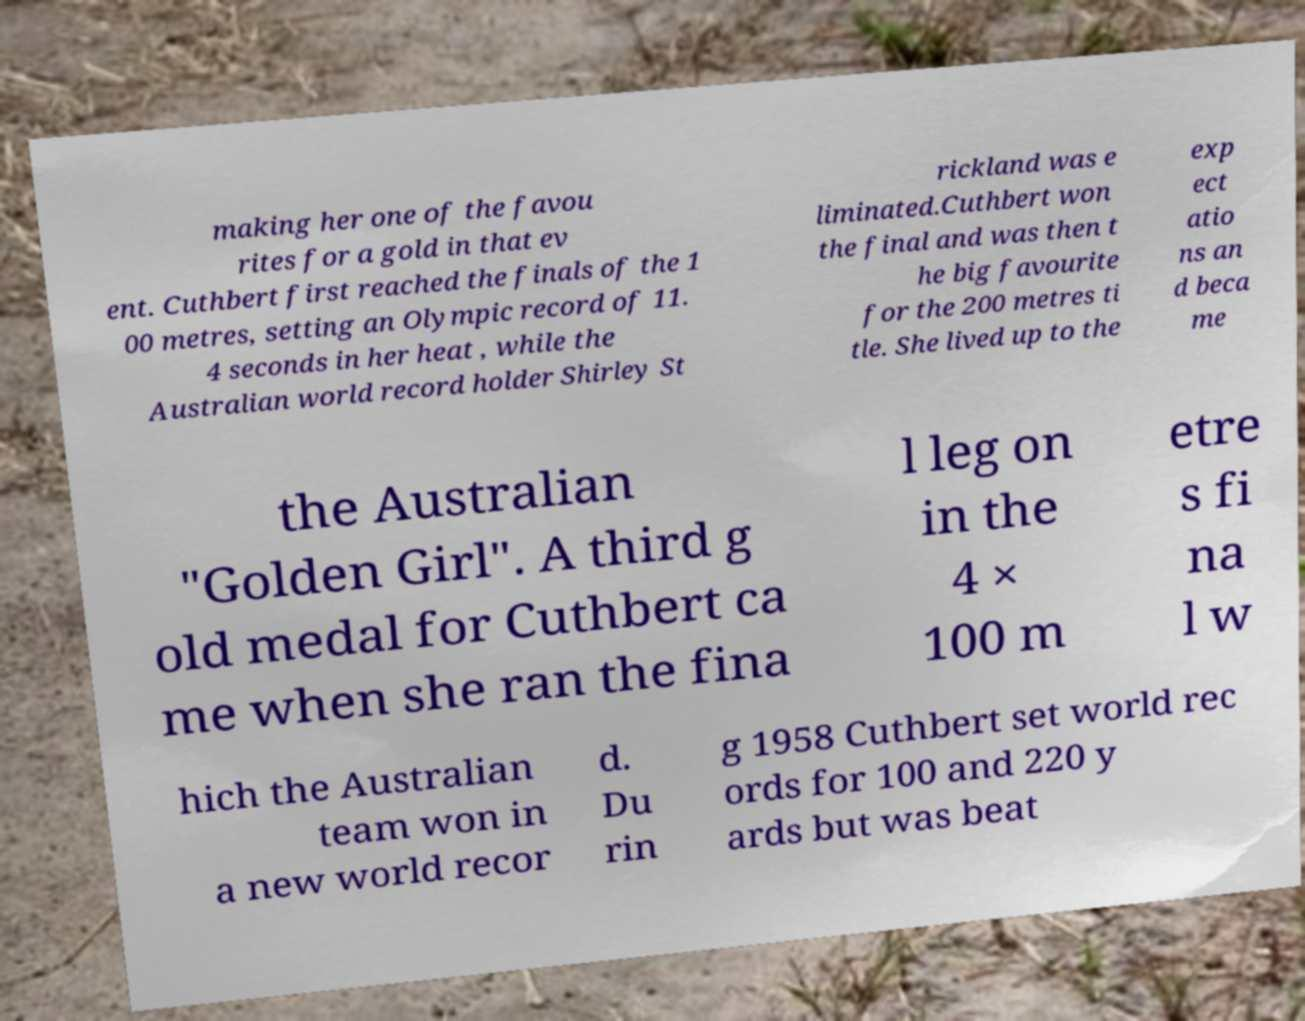Can you read and provide the text displayed in the image?This photo seems to have some interesting text. Can you extract and type it out for me? making her one of the favou rites for a gold in that ev ent. Cuthbert first reached the finals of the 1 00 metres, setting an Olympic record of 11. 4 seconds in her heat , while the Australian world record holder Shirley St rickland was e liminated.Cuthbert won the final and was then t he big favourite for the 200 metres ti tle. She lived up to the exp ect atio ns an d beca me the Australian "Golden Girl". A third g old medal for Cuthbert ca me when she ran the fina l leg on in the 4 × 100 m etre s fi na l w hich the Australian team won in a new world recor d. Du rin g 1958 Cuthbert set world rec ords for 100 and 220 y ards but was beat 